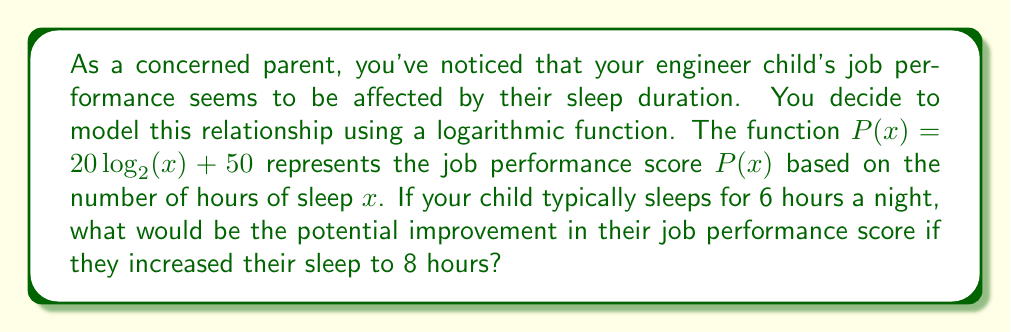Teach me how to tackle this problem. To solve this problem, we need to follow these steps:

1. Calculate the job performance score for 6 hours of sleep:
   $P(6) = 20 \log_2(6) + 50$
   
   First, let's calculate $\log_2(6)$:
   $\log_2(6) \approx 2.5850$
   
   Now, we can complete the calculation:
   $P(6) = 20 \cdot 2.5850 + 50 \approx 101.70$

2. Calculate the job performance score for 8 hours of sleep:
   $P(8) = 20 \log_2(8) + 50$
   
   First, calculate $\log_2(8)$:
   $\log_2(8) = 3$ (since $2^3 = 8$)
   
   Now, we can complete the calculation:
   $P(8) = 20 \cdot 3 + 50 = 110$

3. Calculate the difference between the two scores:
   Improvement = $P(8) - P(6) = 110 - 101.70 = 8.30$

Therefore, increasing sleep from 6 hours to 8 hours would potentially improve the job performance score by approximately 8.30 points.
Answer: The potential improvement in job performance score by increasing sleep from 6 to 8 hours is approximately 8.30 points. 